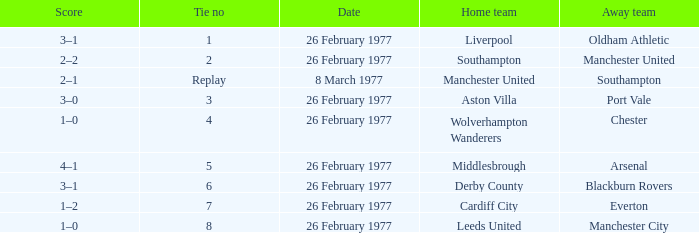What's the tally when the wolverhampton wanderers participated at home? 1–0. 